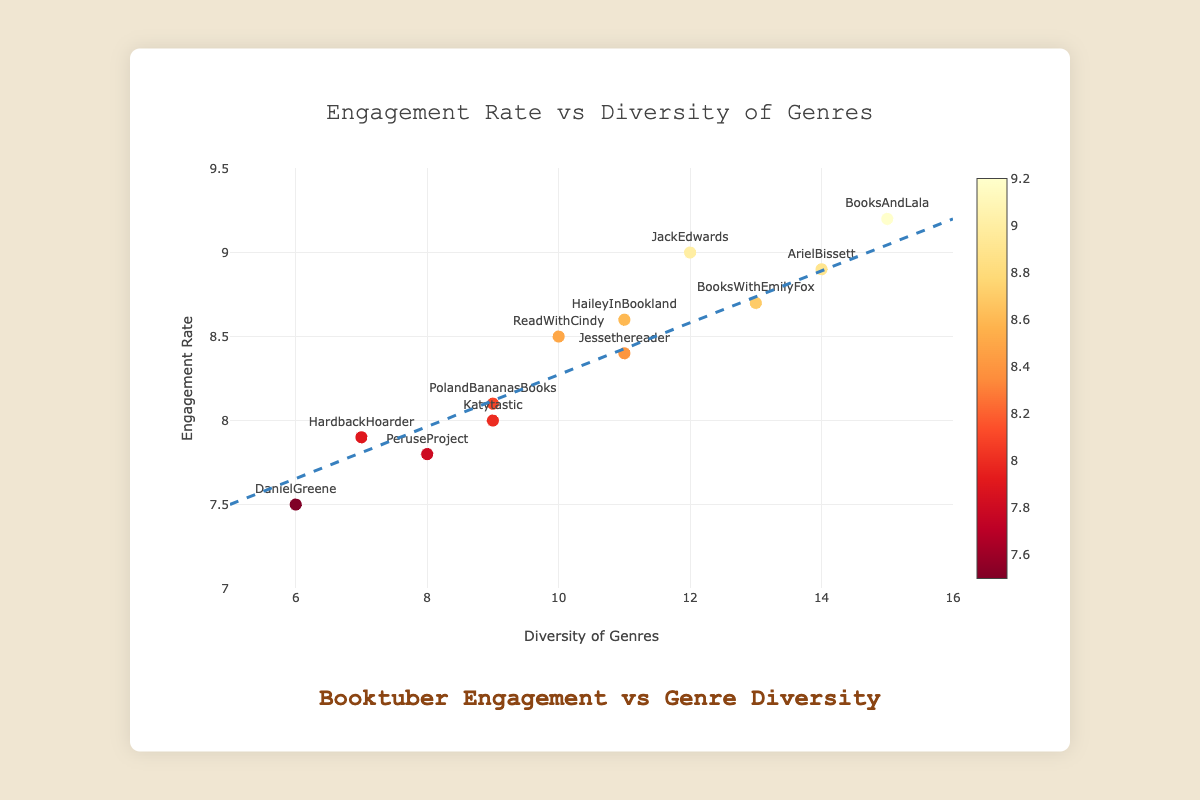What is the title of the figure? The title prominently appears at the top of the figure, reading "Booktuber Engagement vs Genre Diversity".
Answer: Booktuber Engagement vs Genre Diversity How many booktubers are represented in the figure? Each marker in the scatter plot represents a booktuber. Count the number of markers to determine the total number, which amounts to 12.
Answer: 12 Which booktuber has the highest engagement rate? The highest engagement rate is marked by "BooksAndLala" at 9.2. Identify this by looking at the y-axis for the highest value recorded.
Answer: BooksAndLala What is the diversity of genres reviewed by "PolandBananasBooks"? Locate the text "PolandBananasBooks" near a marker, and trace its x-axis value, which corresponds to the diversity of genres reviewed, equal to 9.
Answer: 9 What is the lowest engagement rate shown on the plot, and which booktuber does it belong to? Observe the y-axis for the smallest value, and identify the booktuber associated with that marker. The lowest engagement rate is 7.5, belonging to "DanielGreene".
Answer: 7.5, DanielGreene What is the average engagement rate of the booktubers? Add the engagement rates of all booktubers and divide by the number of data points: (8.5 + 9.2 + 7.8 + 9.0 + 8.9 + 8.1 + 8.6 + 7.5 + 8.7 + 7.9 + 8.4 + 8.0) / 12 = 8.325.
Answer: 8.325 Which two booktubers have the closest engagement rate? Compare the engagement rates: "PeruseProject" (7.8) and "HardbackHoarder" (7.9) have the smallest difference of 0.1.
Answer: PeruseProject and HardbackHoarder What is the trend observed in the relationship between genre diversity and engagement rate? The trend line in the plot appears to be positively sloped, indicating that as the diversity of genres reviewed increases, the engagement rate also tends to increase.
Answer: Positive correlation How many booktubers review 12 or more genres? Identify the markers at or beyond 12 on the x-axis and count them: "JackEdwards" (12), "ArielBissett" (14), "BooksWithEmilyFox" (13), and "BooksAndLala" (15), totaling 4.
Answer: 4 What is the engagement rate of "Jessethereader" and how does it compare to "HaileyInBookland"? Locate "Jessethereader" and "HaileyInBookland" on the plot. "Jessethereader" has an engagement rate of 8.4, while "HaileyInBookland" has 8.6. Hence, "HaileyInBookland" has a slightly higher engagement rate.
Answer: 8.4 for Jessethereader; HaileyInBookland is higher 